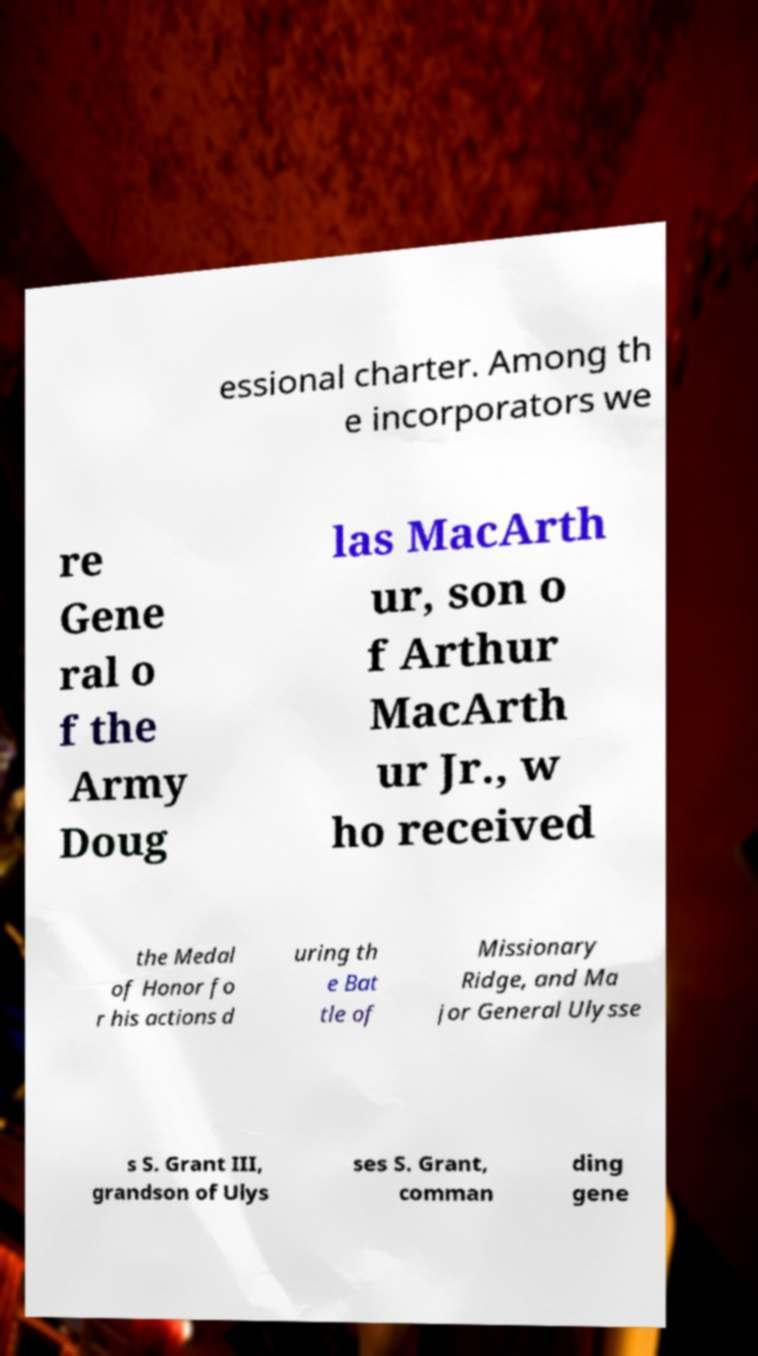Could you assist in decoding the text presented in this image and type it out clearly? essional charter. Among th e incorporators we re Gene ral o f the Army Doug las MacArth ur, son o f Arthur MacArth ur Jr., w ho received the Medal of Honor fo r his actions d uring th e Bat tle of Missionary Ridge, and Ma jor General Ulysse s S. Grant III, grandson of Ulys ses S. Grant, comman ding gene 